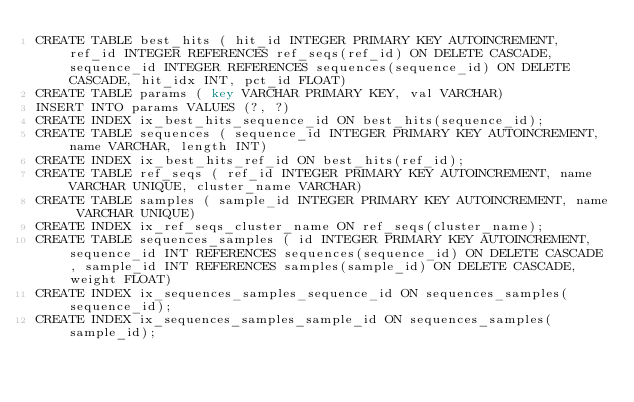Convert code to text. <code><loc_0><loc_0><loc_500><loc_500><_SQL_>CREATE TABLE best_hits ( hit_id INTEGER PRIMARY KEY AUTOINCREMENT, ref_id INTEGER REFERENCES ref_seqs(ref_id) ON DELETE CASCADE, sequence_id INTEGER REFERENCES sequences(sequence_id) ON DELETE CASCADE, hit_idx INT, pct_id FLOAT)
CREATE TABLE params ( key VARCHAR PRIMARY KEY, val VARCHAR)
INSERT INTO params VALUES (?, ?)
CREATE INDEX ix_best_hits_sequence_id ON best_hits(sequence_id);
CREATE TABLE sequences ( sequence_id INTEGER PRIMARY KEY AUTOINCREMENT, name VARCHAR, length INT)
CREATE INDEX ix_best_hits_ref_id ON best_hits(ref_id);
CREATE TABLE ref_seqs ( ref_id INTEGER PRIMARY KEY AUTOINCREMENT, name VARCHAR UNIQUE, cluster_name VARCHAR)
CREATE TABLE samples ( sample_id INTEGER PRIMARY KEY AUTOINCREMENT, name VARCHAR UNIQUE)
CREATE INDEX ix_ref_seqs_cluster_name ON ref_seqs(cluster_name);
CREATE TABLE sequences_samples ( id INTEGER PRIMARY KEY AUTOINCREMENT, sequence_id INT REFERENCES sequences(sequence_id) ON DELETE CASCADE, sample_id INT REFERENCES samples(sample_id) ON DELETE CASCADE, weight FLOAT)
CREATE INDEX ix_sequences_samples_sequence_id ON sequences_samples(sequence_id);
CREATE INDEX ix_sequences_samples_sample_id ON sequences_samples(sample_id);
</code> 